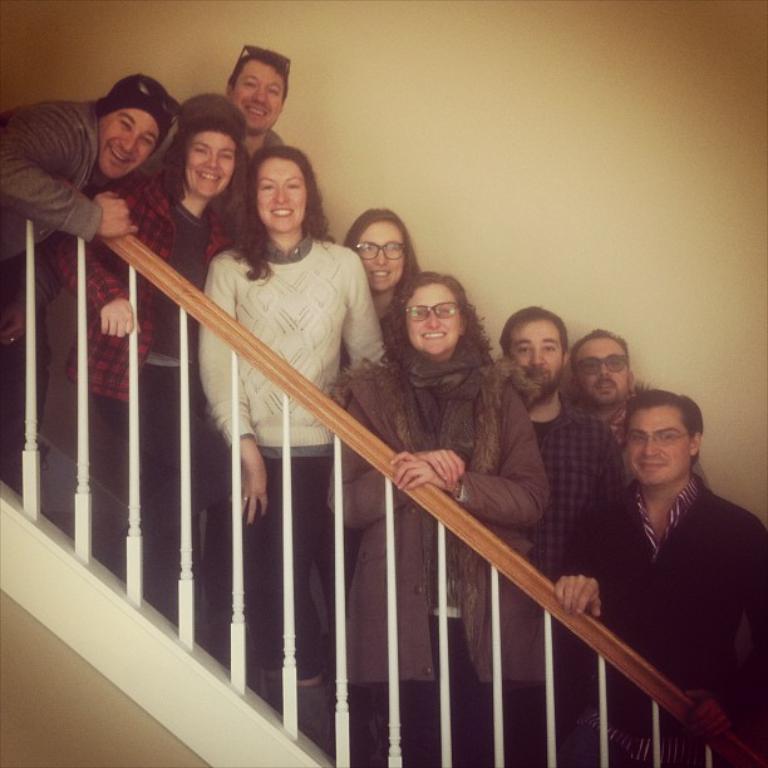Describe this image in one or two sentences. In this image I can see there are few persons standing in front of the fence and I can see white color wall visible back side of them. 